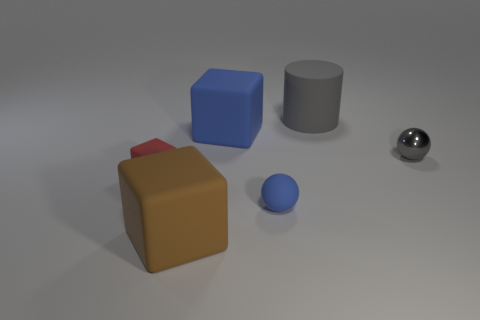Add 1 tiny cubes. How many objects exist? 7 Subtract all balls. How many objects are left? 4 Subtract all big purple matte balls. Subtract all blue matte spheres. How many objects are left? 5 Add 5 big brown rubber things. How many big brown rubber things are left? 6 Add 6 big rubber cylinders. How many big rubber cylinders exist? 7 Subtract 1 red blocks. How many objects are left? 5 